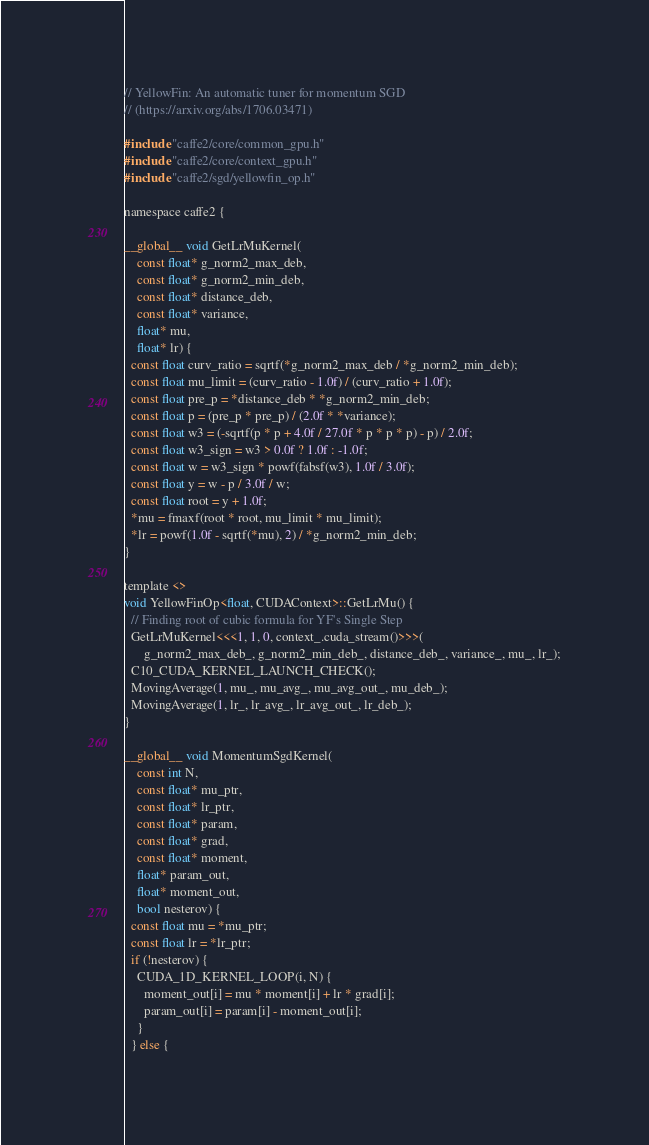Convert code to text. <code><loc_0><loc_0><loc_500><loc_500><_Cuda_>// YellowFin: An automatic tuner for momentum SGD
// (https://arxiv.org/abs/1706.03471)

#include "caffe2/core/common_gpu.h"
#include "caffe2/core/context_gpu.h"
#include "caffe2/sgd/yellowfin_op.h"

namespace caffe2 {

__global__ void GetLrMuKernel(
    const float* g_norm2_max_deb,
    const float* g_norm2_min_deb,
    const float* distance_deb,
    const float* variance,
    float* mu,
    float* lr) {
  const float curv_ratio = sqrtf(*g_norm2_max_deb / *g_norm2_min_deb);
  const float mu_limit = (curv_ratio - 1.0f) / (curv_ratio + 1.0f);
  const float pre_p = *distance_deb * *g_norm2_min_deb;
  const float p = (pre_p * pre_p) / (2.0f * *variance);
  const float w3 = (-sqrtf(p * p + 4.0f / 27.0f * p * p * p) - p) / 2.0f;
  const float w3_sign = w3 > 0.0f ? 1.0f : -1.0f;
  const float w = w3_sign * powf(fabsf(w3), 1.0f / 3.0f);
  const float y = w - p / 3.0f / w;
  const float root = y + 1.0f;
  *mu = fmaxf(root * root, mu_limit * mu_limit);
  *lr = powf(1.0f - sqrtf(*mu), 2) / *g_norm2_min_deb;
}

template <>
void YellowFinOp<float, CUDAContext>::GetLrMu() {
  // Finding root of cubic formula for YF's Single Step
  GetLrMuKernel<<<1, 1, 0, context_.cuda_stream()>>>(
      g_norm2_max_deb_, g_norm2_min_deb_, distance_deb_, variance_, mu_, lr_);
  C10_CUDA_KERNEL_LAUNCH_CHECK();
  MovingAverage(1, mu_, mu_avg_, mu_avg_out_, mu_deb_);
  MovingAverage(1, lr_, lr_avg_, lr_avg_out_, lr_deb_);
}

__global__ void MomentumSgdKernel(
    const int N,
    const float* mu_ptr,
    const float* lr_ptr,
    const float* param,
    const float* grad,
    const float* moment,
    float* param_out,
    float* moment_out,
    bool nesterov) {
  const float mu = *mu_ptr;
  const float lr = *lr_ptr;
  if (!nesterov) {
    CUDA_1D_KERNEL_LOOP(i, N) {
      moment_out[i] = mu * moment[i] + lr * grad[i];
      param_out[i] = param[i] - moment_out[i];
    }
  } else {</code> 